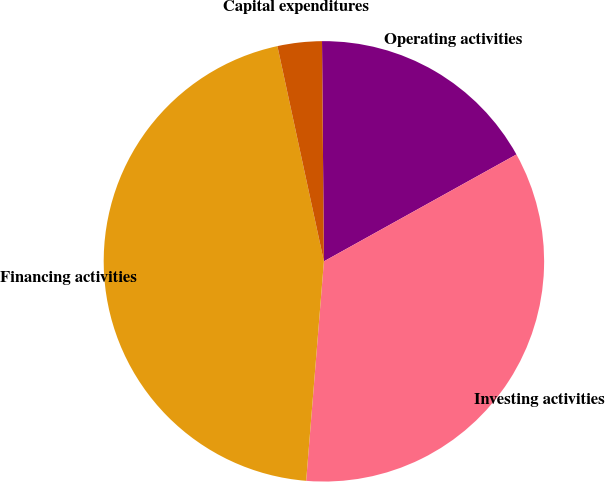Convert chart. <chart><loc_0><loc_0><loc_500><loc_500><pie_chart><fcel>Operating activities<fcel>Investing activities<fcel>Financing activities<fcel>Capital expenditures<nl><fcel>17.07%<fcel>34.35%<fcel>45.33%<fcel>3.25%<nl></chart> 